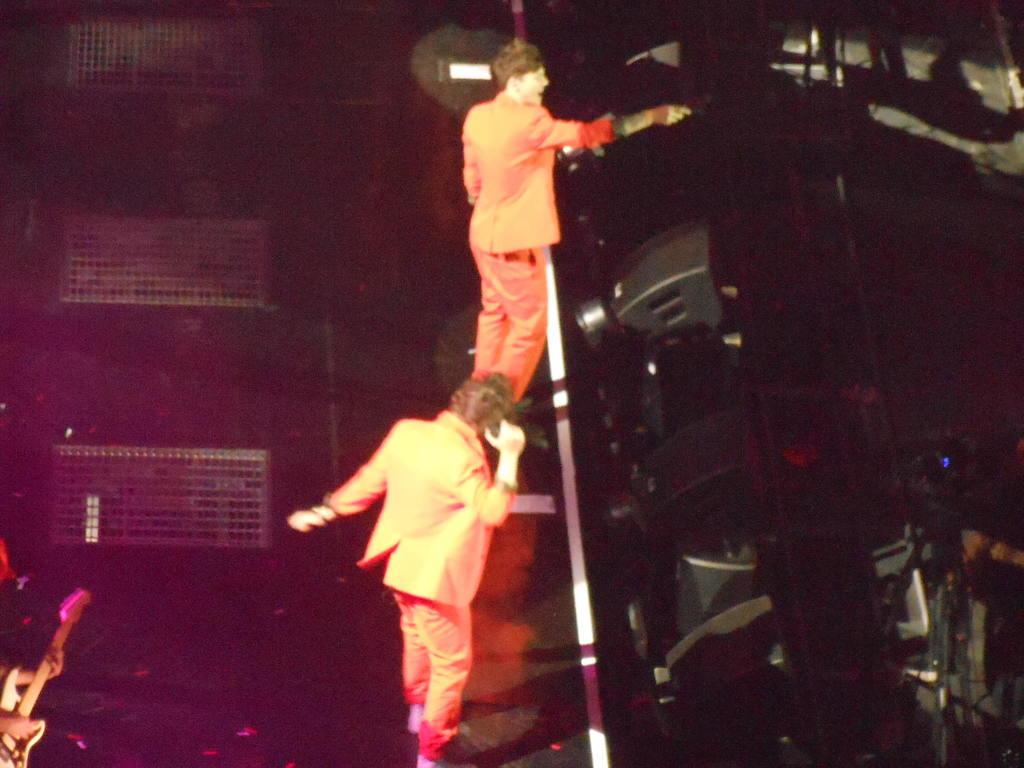How many people are in the image? There are two persons standing in the center of the image. What is the person on the left side of the image holding? The person on the left side of the image is holding a guitar. Can you describe the background of the image? There are musical instruments visible in the background of the image. What type of crime is being committed by the goat in the image? There is no goat present in the image, and therefore no crime can be committed by a goat. How many nails are visible in the image? There is no mention of nails in the provided facts, so we cannot determine the number of nails visible in the image. 